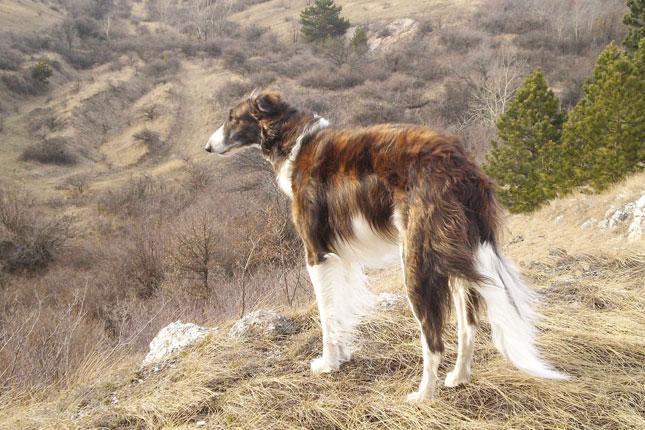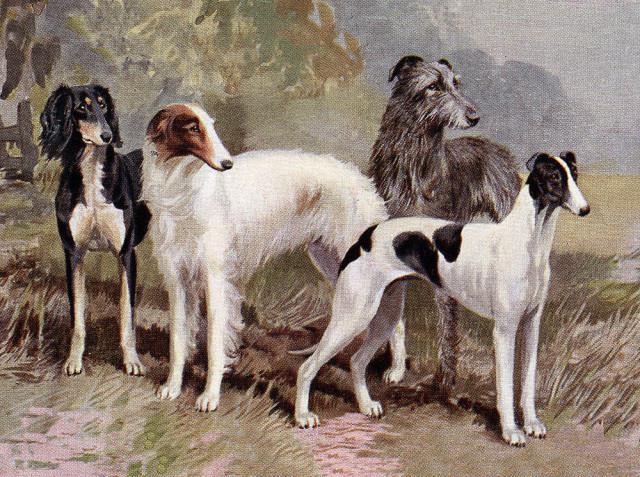The first image is the image on the left, the second image is the image on the right. Analyze the images presented: Is the assertion "There is one dog in one of the images, and four or more dogs in the other image." valid? Answer yes or no. Yes. The first image is the image on the left, the second image is the image on the right. For the images displayed, is the sentence "A person is standing with the dog in the image on the right." factually correct? Answer yes or no. No. 